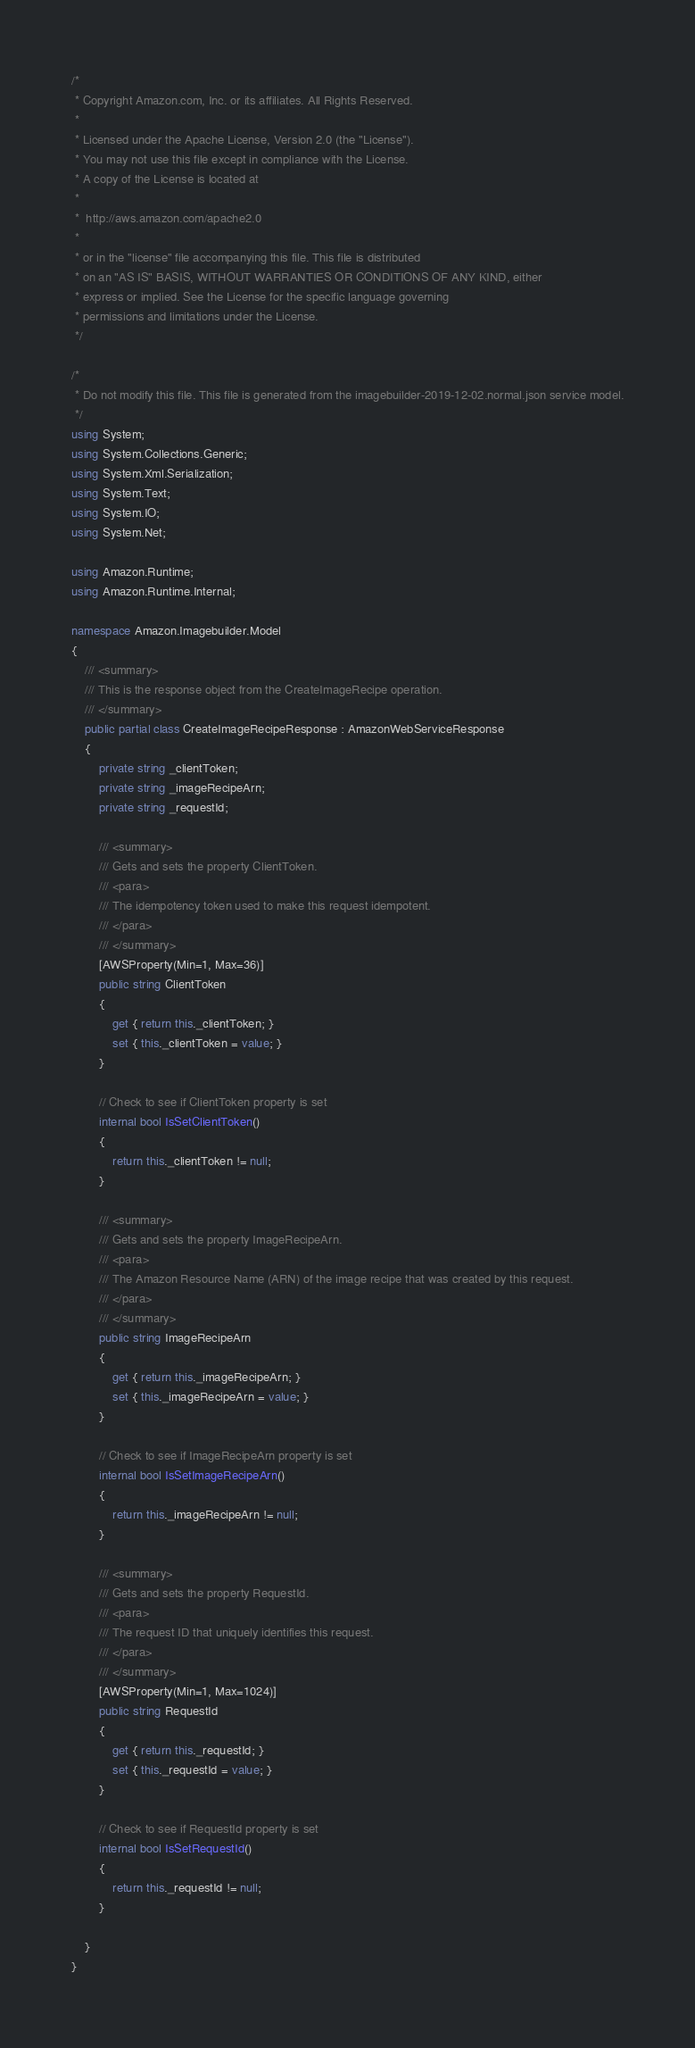Convert code to text. <code><loc_0><loc_0><loc_500><loc_500><_C#_>/*
 * Copyright Amazon.com, Inc. or its affiliates. All Rights Reserved.
 * 
 * Licensed under the Apache License, Version 2.0 (the "License").
 * You may not use this file except in compliance with the License.
 * A copy of the License is located at
 * 
 *  http://aws.amazon.com/apache2.0
 * 
 * or in the "license" file accompanying this file. This file is distributed
 * on an "AS IS" BASIS, WITHOUT WARRANTIES OR CONDITIONS OF ANY KIND, either
 * express or implied. See the License for the specific language governing
 * permissions and limitations under the License.
 */

/*
 * Do not modify this file. This file is generated from the imagebuilder-2019-12-02.normal.json service model.
 */
using System;
using System.Collections.Generic;
using System.Xml.Serialization;
using System.Text;
using System.IO;
using System.Net;

using Amazon.Runtime;
using Amazon.Runtime.Internal;

namespace Amazon.Imagebuilder.Model
{
    /// <summary>
    /// This is the response object from the CreateImageRecipe operation.
    /// </summary>
    public partial class CreateImageRecipeResponse : AmazonWebServiceResponse
    {
        private string _clientToken;
        private string _imageRecipeArn;
        private string _requestId;

        /// <summary>
        /// Gets and sets the property ClientToken. 
        /// <para>
        /// The idempotency token used to make this request idempotent.
        /// </para>
        /// </summary>
        [AWSProperty(Min=1, Max=36)]
        public string ClientToken
        {
            get { return this._clientToken; }
            set { this._clientToken = value; }
        }

        // Check to see if ClientToken property is set
        internal bool IsSetClientToken()
        {
            return this._clientToken != null;
        }

        /// <summary>
        /// Gets and sets the property ImageRecipeArn. 
        /// <para>
        /// The Amazon Resource Name (ARN) of the image recipe that was created by this request.
        /// </para>
        /// </summary>
        public string ImageRecipeArn
        {
            get { return this._imageRecipeArn; }
            set { this._imageRecipeArn = value; }
        }

        // Check to see if ImageRecipeArn property is set
        internal bool IsSetImageRecipeArn()
        {
            return this._imageRecipeArn != null;
        }

        /// <summary>
        /// Gets and sets the property RequestId. 
        /// <para>
        /// The request ID that uniquely identifies this request.
        /// </para>
        /// </summary>
        [AWSProperty(Min=1, Max=1024)]
        public string RequestId
        {
            get { return this._requestId; }
            set { this._requestId = value; }
        }

        // Check to see if RequestId property is set
        internal bool IsSetRequestId()
        {
            return this._requestId != null;
        }

    }
}</code> 